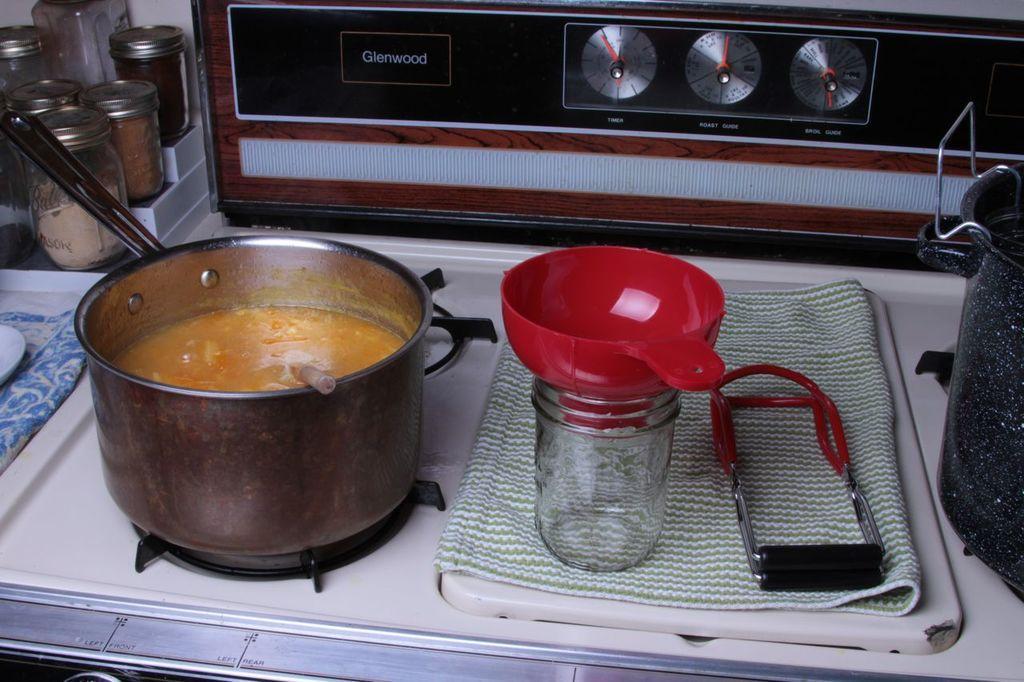Describe this image in one or two sentences. On a stove there is a container, in this container there is a food. On this cloth there is a jar and strainer. On corner of this table there are jars with lid. 